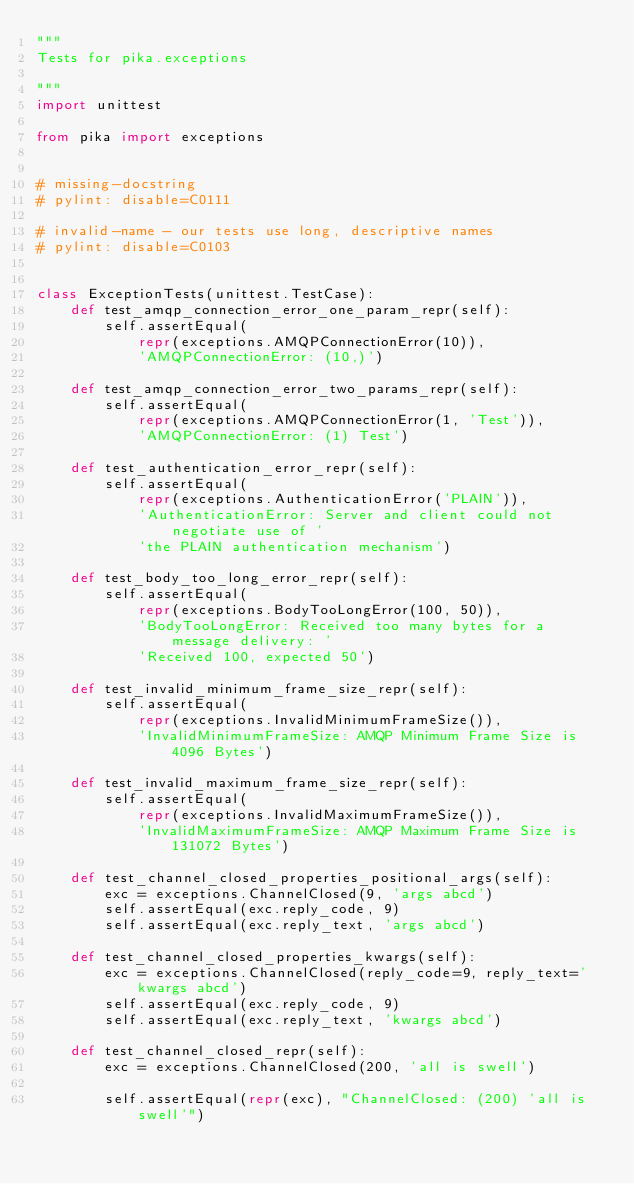<code> <loc_0><loc_0><loc_500><loc_500><_Python_>"""
Tests for pika.exceptions

"""
import unittest

from pika import exceptions


# missing-docstring
# pylint: disable=C0111

# invalid-name - our tests use long, descriptive names
# pylint: disable=C0103


class ExceptionTests(unittest.TestCase):
    def test_amqp_connection_error_one_param_repr(self):
        self.assertEqual(
            repr(exceptions.AMQPConnectionError(10)),
            'AMQPConnectionError: (10,)')

    def test_amqp_connection_error_two_params_repr(self):
        self.assertEqual(
            repr(exceptions.AMQPConnectionError(1, 'Test')),
            'AMQPConnectionError: (1) Test')

    def test_authentication_error_repr(self):
        self.assertEqual(
            repr(exceptions.AuthenticationError('PLAIN')),
            'AuthenticationError: Server and client could not negotiate use of '
            'the PLAIN authentication mechanism')

    def test_body_too_long_error_repr(self):
        self.assertEqual(
            repr(exceptions.BodyTooLongError(100, 50)),
            'BodyTooLongError: Received too many bytes for a message delivery: '
            'Received 100, expected 50')

    def test_invalid_minimum_frame_size_repr(self):
        self.assertEqual(
            repr(exceptions.InvalidMinimumFrameSize()),
            'InvalidMinimumFrameSize: AMQP Minimum Frame Size is 4096 Bytes')

    def test_invalid_maximum_frame_size_repr(self):
        self.assertEqual(
            repr(exceptions.InvalidMaximumFrameSize()),
            'InvalidMaximumFrameSize: AMQP Maximum Frame Size is 131072 Bytes')

    def test_channel_closed_properties_positional_args(self):
        exc = exceptions.ChannelClosed(9, 'args abcd')
        self.assertEqual(exc.reply_code, 9)
        self.assertEqual(exc.reply_text, 'args abcd')

    def test_channel_closed_properties_kwargs(self):
        exc = exceptions.ChannelClosed(reply_code=9, reply_text='kwargs abcd')
        self.assertEqual(exc.reply_code, 9)
        self.assertEqual(exc.reply_text, 'kwargs abcd')

    def test_channel_closed_repr(self):
        exc = exceptions.ChannelClosed(200, 'all is swell')

        self.assertEqual(repr(exc), "ChannelClosed: (200) 'all is swell'")
</code> 